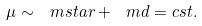<formula> <loc_0><loc_0><loc_500><loc_500>\mu \sim \ m s t a r + \ m d = c s t .</formula> 